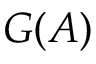<formula> <loc_0><loc_0><loc_500><loc_500>G ( A )</formula> 